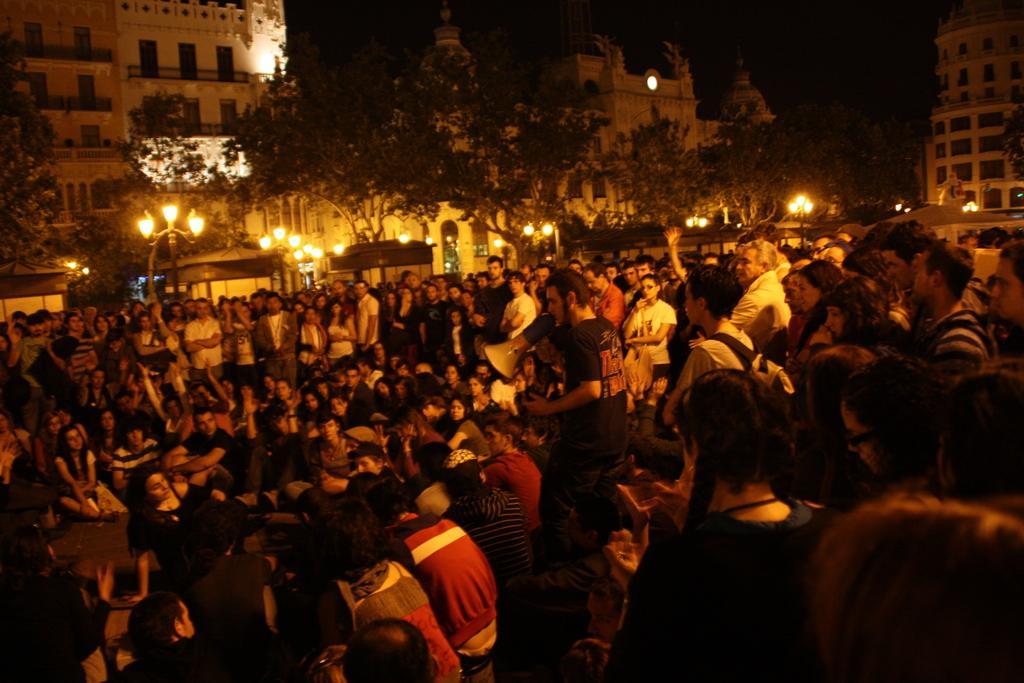In one or two sentences, can you explain what this image depicts? In this image I can see number of people were few people are sitting and most of them are standing. In the centre I can see one of them is holding a megaphone. In the background I can see number of trees, number of poles, number of lights and few buildings. 